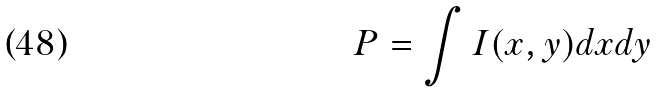<formula> <loc_0><loc_0><loc_500><loc_500>P = \int I ( x , y ) d x d y</formula> 